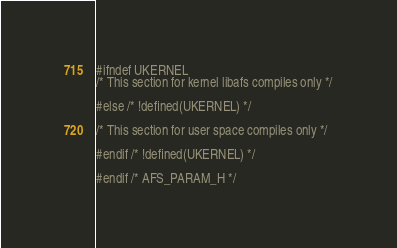Convert code to text. <code><loc_0><loc_0><loc_500><loc_500><_C_>#ifndef UKERNEL
/* This section for kernel libafs compiles only */

#else /* !defined(UKERNEL) */

/* This section for user space compiles only */

#endif /* !defined(UKERNEL) */

#endif /* AFS_PARAM_H */
</code> 